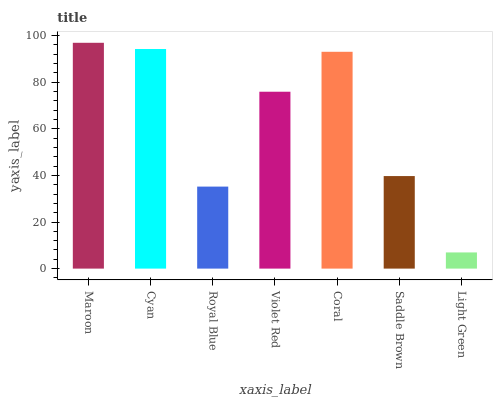Is Light Green the minimum?
Answer yes or no. Yes. Is Maroon the maximum?
Answer yes or no. Yes. Is Cyan the minimum?
Answer yes or no. No. Is Cyan the maximum?
Answer yes or no. No. Is Maroon greater than Cyan?
Answer yes or no. Yes. Is Cyan less than Maroon?
Answer yes or no. Yes. Is Cyan greater than Maroon?
Answer yes or no. No. Is Maroon less than Cyan?
Answer yes or no. No. Is Violet Red the high median?
Answer yes or no. Yes. Is Violet Red the low median?
Answer yes or no. Yes. Is Light Green the high median?
Answer yes or no. No. Is Light Green the low median?
Answer yes or no. No. 